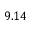Convert formula to latex. <formula><loc_0><loc_0><loc_500><loc_500>9 . 1 4</formula> 